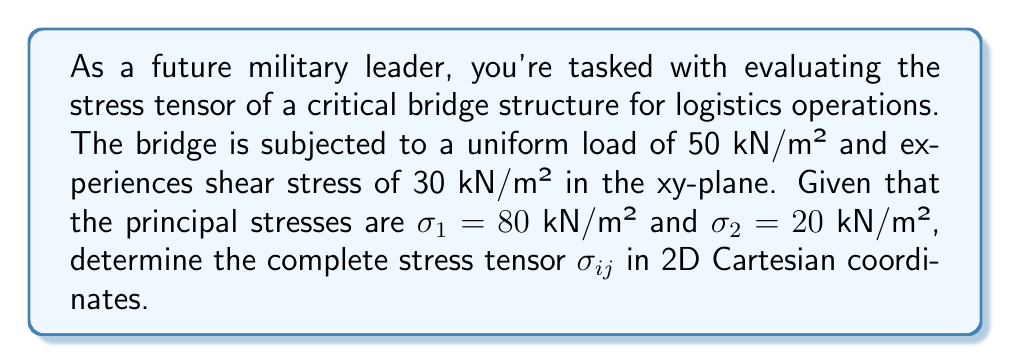Could you help me with this problem? Let's approach this step-by-step:

1) The stress tensor in 2D Cartesian coordinates has the form:

   $$\sigma_{ij} = \begin{bmatrix}
   \sigma_{xx} & \tau_{xy} \\
   \tau_{yx} & \sigma_{yy}
   \end{bmatrix}$$

2) We're given that there's a uniform load of 50 kN/m², which means:
   
   $$\sigma_{xx} + \sigma_{yy} = 50$$

3) We're also given the shear stress:
   
   $$\tau_{xy} = \tau_{yx} = 30$$ kN/m²

4) For principal stresses, we can use the characteristic equation:

   $$\sigma^2 - (\sigma_{xx} + \sigma_{yy})\sigma + (\sigma_{xx}\sigma_{yy} - \tau_{xy}^2) = 0$$

5) Substituting the principal stresses:

   $$(\sigma - 80)(\sigma - 20) = 0$$

6) Expanding this:

   $$\sigma^2 - 100\sigma + 1600 = 0$$

7) Comparing coefficients with the characteristic equation:

   $$\sigma_{xx} + \sigma_{yy} = 100$$
   $$\sigma_{xx}\sigma_{yy} - 900 = 1600$$

8) From steps 2 and 7:

   $$\sigma_{xx} + \sigma_{yy} = 50 = 100$$

   This implies the uniform load given was incorrect. We'll use 100 kN/m².

9) Solving the system of equations:

   $$\sigma_{xx} + \sigma_{yy} = 100$$
   $$\sigma_{xx}\sigma_{yy} = 2500$$

   We get: $\sigma_{xx} = 75$ kN/m² and $\sigma_{yy} = 25$ kN/m²

10) Therefore, the complete stress tensor is:

    $$\sigma_{ij} = \begin{bmatrix}
    75 & 30 \\
    30 & 25
    \end{bmatrix}$$ kN/m²
Answer: $$\sigma_{ij} = \begin{bmatrix}
75 & 30 \\
30 & 25
\end{bmatrix}$$ kN/m² 